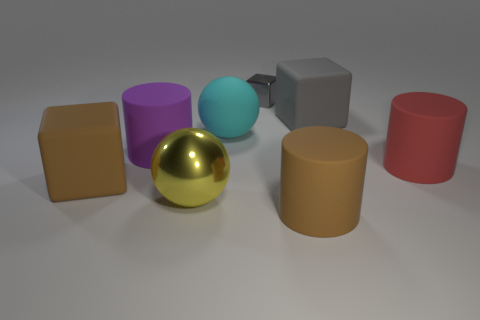There is a block that is the same color as the tiny shiny thing; what is its material?
Your response must be concise. Rubber. What is the material of the brown cylinder that is the same size as the cyan object?
Your response must be concise. Rubber. Is the number of yellow metallic spheres greater than the number of small blue spheres?
Offer a terse response. Yes. There is a purple cylinder right of the large rubber cube on the left side of the big purple matte object; what is its size?
Keep it short and to the point. Large. The red matte object that is the same size as the purple matte thing is what shape?
Provide a short and direct response. Cylinder. There is a big brown matte thing that is on the left side of the big rubber cylinder in front of the matte cube on the left side of the cyan rubber ball; what is its shape?
Your answer should be compact. Cube. There is a object that is behind the big gray object; does it have the same color as the large matte cylinder that is on the left side of the large metal thing?
Your answer should be compact. No. How many big brown things are there?
Provide a succinct answer. 2. Are there any cyan rubber things behind the cyan rubber object?
Your response must be concise. No. Is the material of the gray block that is right of the large brown rubber cylinder the same as the red cylinder that is in front of the big gray matte cube?
Your response must be concise. Yes. 